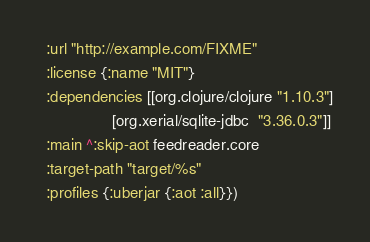<code> <loc_0><loc_0><loc_500><loc_500><_Clojure_>  :url "http://example.com/FIXME"
  :license {:name "MIT"}
  :dependencies [[org.clojure/clojure "1.10.3"]
                 [org.xerial/sqlite-jdbc  "3.36.0.3"]]
  :main ^:skip-aot feedreader.core
  :target-path "target/%s"
  :profiles {:uberjar {:aot :all}})
</code> 